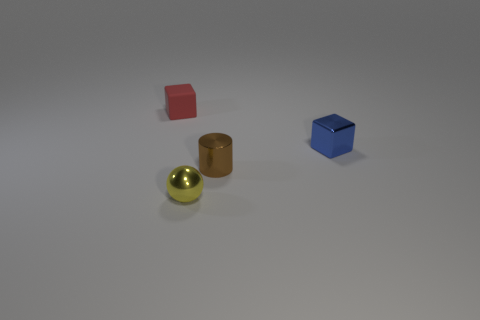Subtract all cylinders. How many objects are left? 3 Add 1 tiny red cubes. How many objects exist? 5 Subtract all gray cylinders. How many red blocks are left? 1 Subtract 1 blocks. How many blocks are left? 1 Subtract all cyan cylinders. Subtract all brown blocks. How many cylinders are left? 1 Subtract all small brown shiny cylinders. Subtract all small cylinders. How many objects are left? 2 Add 4 yellow balls. How many yellow balls are left? 5 Add 3 small red balls. How many small red balls exist? 3 Subtract 1 brown cylinders. How many objects are left? 3 